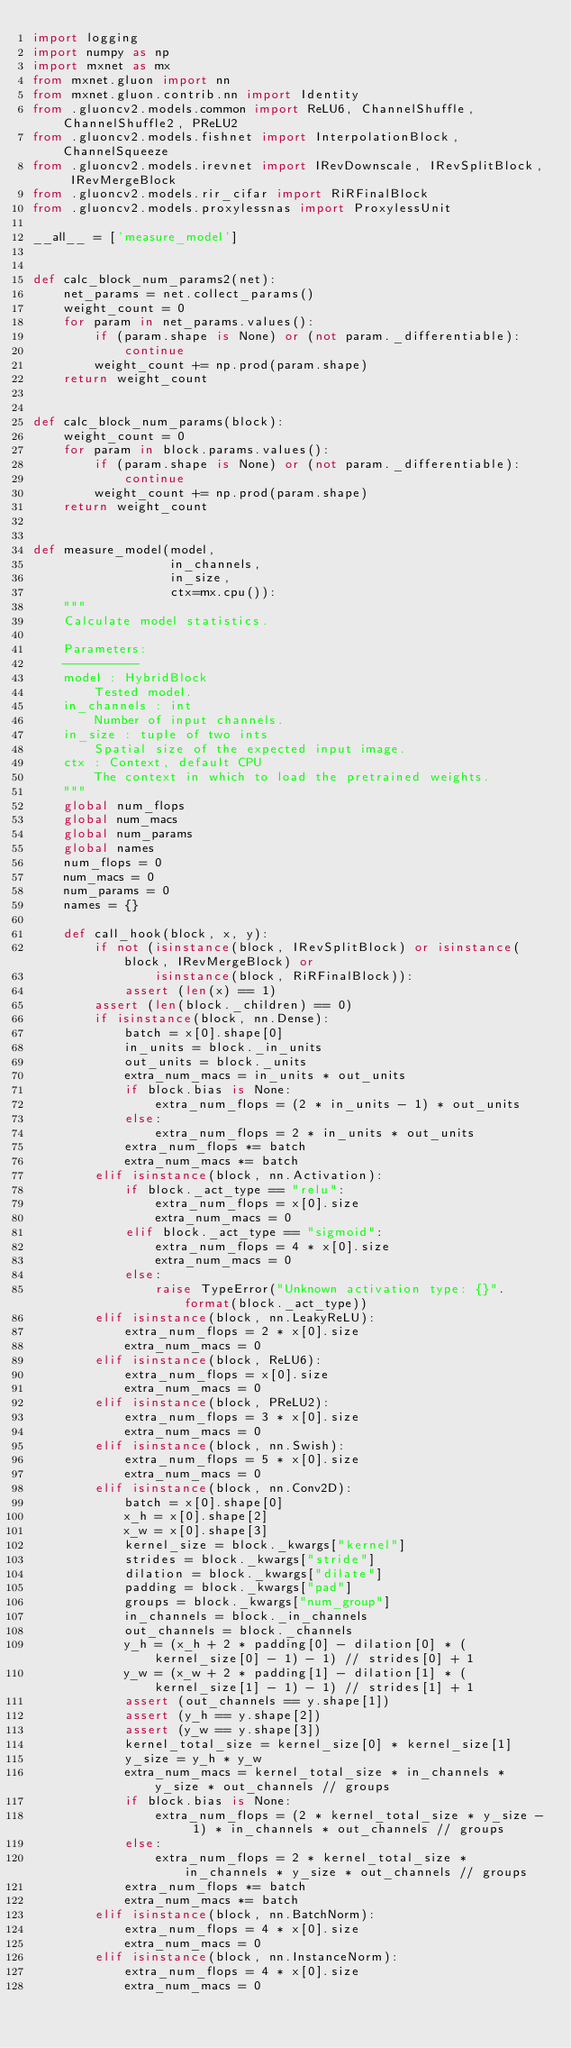Convert code to text. <code><loc_0><loc_0><loc_500><loc_500><_Python_>import logging
import numpy as np
import mxnet as mx
from mxnet.gluon import nn
from mxnet.gluon.contrib.nn import Identity
from .gluoncv2.models.common import ReLU6, ChannelShuffle, ChannelShuffle2, PReLU2
from .gluoncv2.models.fishnet import InterpolationBlock, ChannelSqueeze
from .gluoncv2.models.irevnet import IRevDownscale, IRevSplitBlock, IRevMergeBlock
from .gluoncv2.models.rir_cifar import RiRFinalBlock
from .gluoncv2.models.proxylessnas import ProxylessUnit

__all__ = ['measure_model']


def calc_block_num_params2(net):
    net_params = net.collect_params()
    weight_count = 0
    for param in net_params.values():
        if (param.shape is None) or (not param._differentiable):
            continue
        weight_count += np.prod(param.shape)
    return weight_count


def calc_block_num_params(block):
    weight_count = 0
    for param in block.params.values():
        if (param.shape is None) or (not param._differentiable):
            continue
        weight_count += np.prod(param.shape)
    return weight_count


def measure_model(model,
                  in_channels,
                  in_size,
                  ctx=mx.cpu()):
    """
    Calculate model statistics.

    Parameters:
    ----------
    model : HybridBlock
        Tested model.
    in_channels : int
        Number of input channels.
    in_size : tuple of two ints
        Spatial size of the expected input image.
    ctx : Context, default CPU
        The context in which to load the pretrained weights.
    """
    global num_flops
    global num_macs
    global num_params
    global names
    num_flops = 0
    num_macs = 0
    num_params = 0
    names = {}

    def call_hook(block, x, y):
        if not (isinstance(block, IRevSplitBlock) or isinstance(block, IRevMergeBlock) or
                isinstance(block, RiRFinalBlock)):
            assert (len(x) == 1)
        assert (len(block._children) == 0)
        if isinstance(block, nn.Dense):
            batch = x[0].shape[0]
            in_units = block._in_units
            out_units = block._units
            extra_num_macs = in_units * out_units
            if block.bias is None:
                extra_num_flops = (2 * in_units - 1) * out_units
            else:
                extra_num_flops = 2 * in_units * out_units
            extra_num_flops *= batch
            extra_num_macs *= batch
        elif isinstance(block, nn.Activation):
            if block._act_type == "relu":
                extra_num_flops = x[0].size
                extra_num_macs = 0
            elif block._act_type == "sigmoid":
                extra_num_flops = 4 * x[0].size
                extra_num_macs = 0
            else:
                raise TypeError("Unknown activation type: {}".format(block._act_type))
        elif isinstance(block, nn.LeakyReLU):
            extra_num_flops = 2 * x[0].size
            extra_num_macs = 0
        elif isinstance(block, ReLU6):
            extra_num_flops = x[0].size
            extra_num_macs = 0
        elif isinstance(block, PReLU2):
            extra_num_flops = 3 * x[0].size
            extra_num_macs = 0
        elif isinstance(block, nn.Swish):
            extra_num_flops = 5 * x[0].size
            extra_num_macs = 0
        elif isinstance(block, nn.Conv2D):
            batch = x[0].shape[0]
            x_h = x[0].shape[2]
            x_w = x[0].shape[3]
            kernel_size = block._kwargs["kernel"]
            strides = block._kwargs["stride"]
            dilation = block._kwargs["dilate"]
            padding = block._kwargs["pad"]
            groups = block._kwargs["num_group"]
            in_channels = block._in_channels
            out_channels = block._channels
            y_h = (x_h + 2 * padding[0] - dilation[0] * (kernel_size[0] - 1) - 1) // strides[0] + 1
            y_w = (x_w + 2 * padding[1] - dilation[1] * (kernel_size[1] - 1) - 1) // strides[1] + 1
            assert (out_channels == y.shape[1])
            assert (y_h == y.shape[2])
            assert (y_w == y.shape[3])
            kernel_total_size = kernel_size[0] * kernel_size[1]
            y_size = y_h * y_w
            extra_num_macs = kernel_total_size * in_channels * y_size * out_channels // groups
            if block.bias is None:
                extra_num_flops = (2 * kernel_total_size * y_size - 1) * in_channels * out_channels // groups
            else:
                extra_num_flops = 2 * kernel_total_size * in_channels * y_size * out_channels // groups
            extra_num_flops *= batch
            extra_num_macs *= batch
        elif isinstance(block, nn.BatchNorm):
            extra_num_flops = 4 * x[0].size
            extra_num_macs = 0
        elif isinstance(block, nn.InstanceNorm):
            extra_num_flops = 4 * x[0].size
            extra_num_macs = 0</code> 